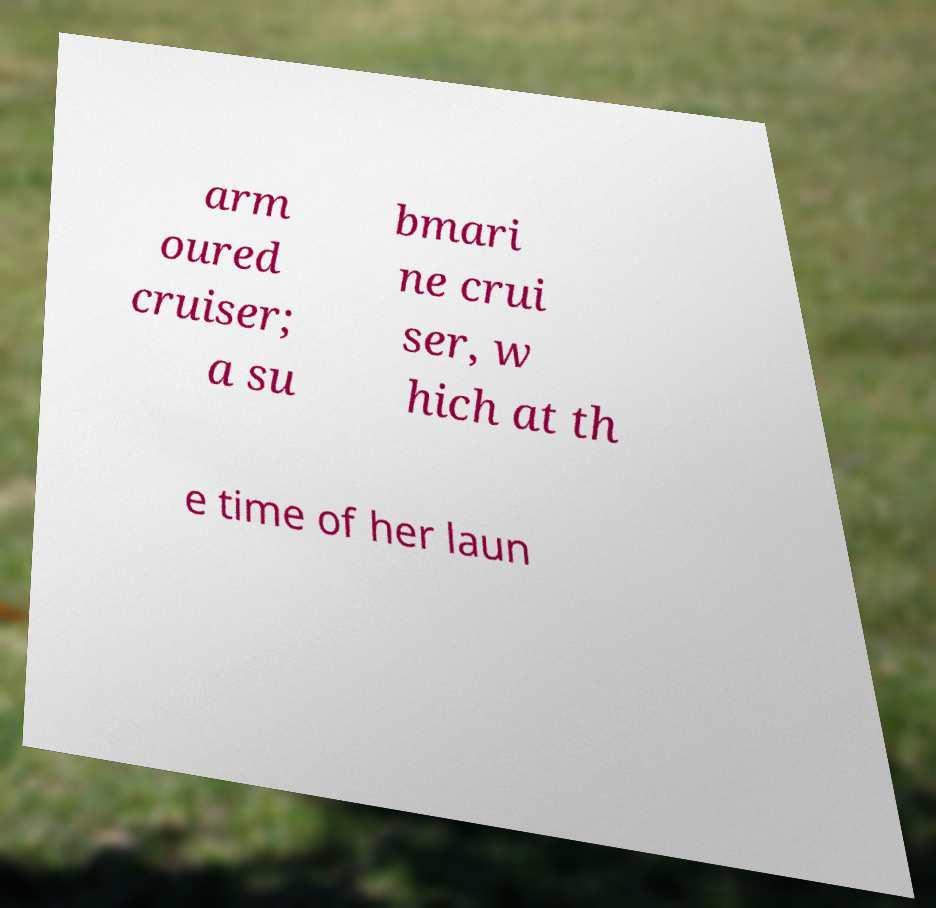I need the written content from this picture converted into text. Can you do that? arm oured cruiser; a su bmari ne crui ser, w hich at th e time of her laun 